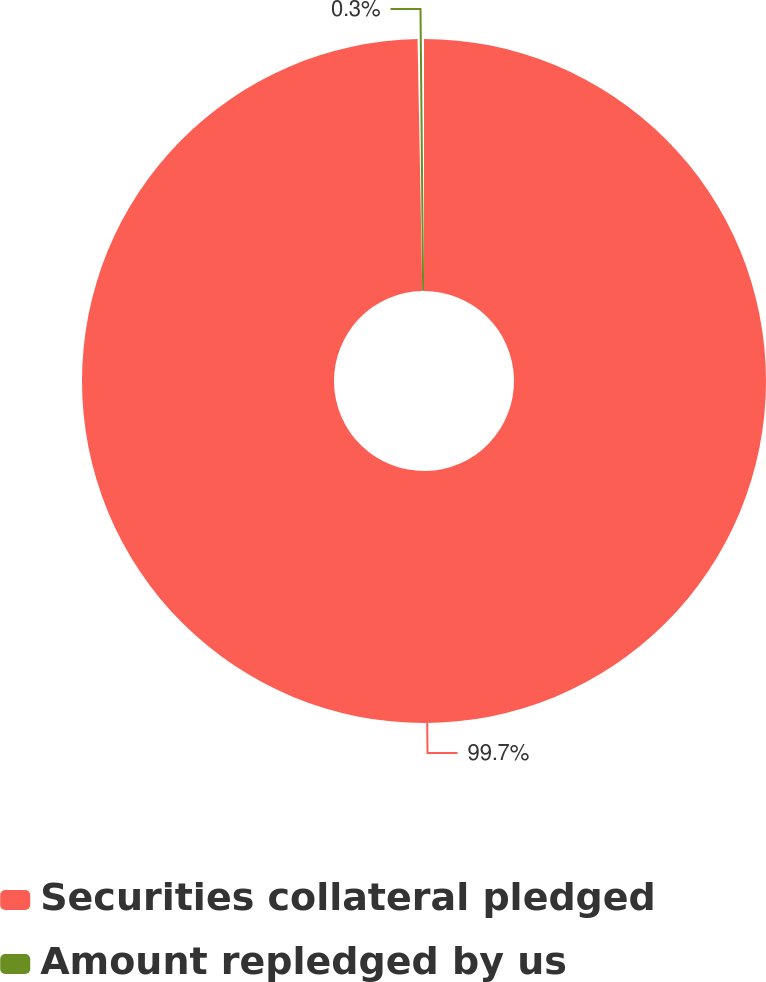Convert chart to OTSL. <chart><loc_0><loc_0><loc_500><loc_500><pie_chart><fcel>Securities collateral pledged<fcel>Amount repledged by us<nl><fcel>99.7%<fcel>0.3%<nl></chart> 